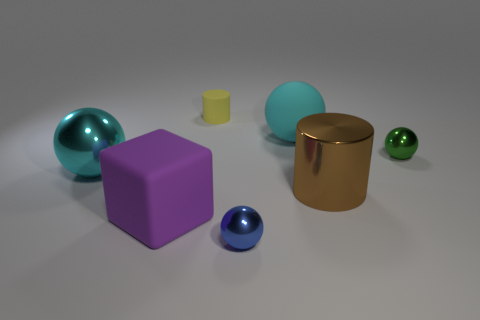Can you describe the different materials and shapes present in this image? Certainly! The image presents a variety of shapes and materials. There's a large, matte purple cube, a shiny teal sphere, a small shiny green sphere, a matte yellow cylinder that's short and wide, a shiny cyan sphere, and a reflective gold cylinder with curved edges. Each object exhibits different attributes in terms of shininess, shape, and color, providing a rich array to observe. 